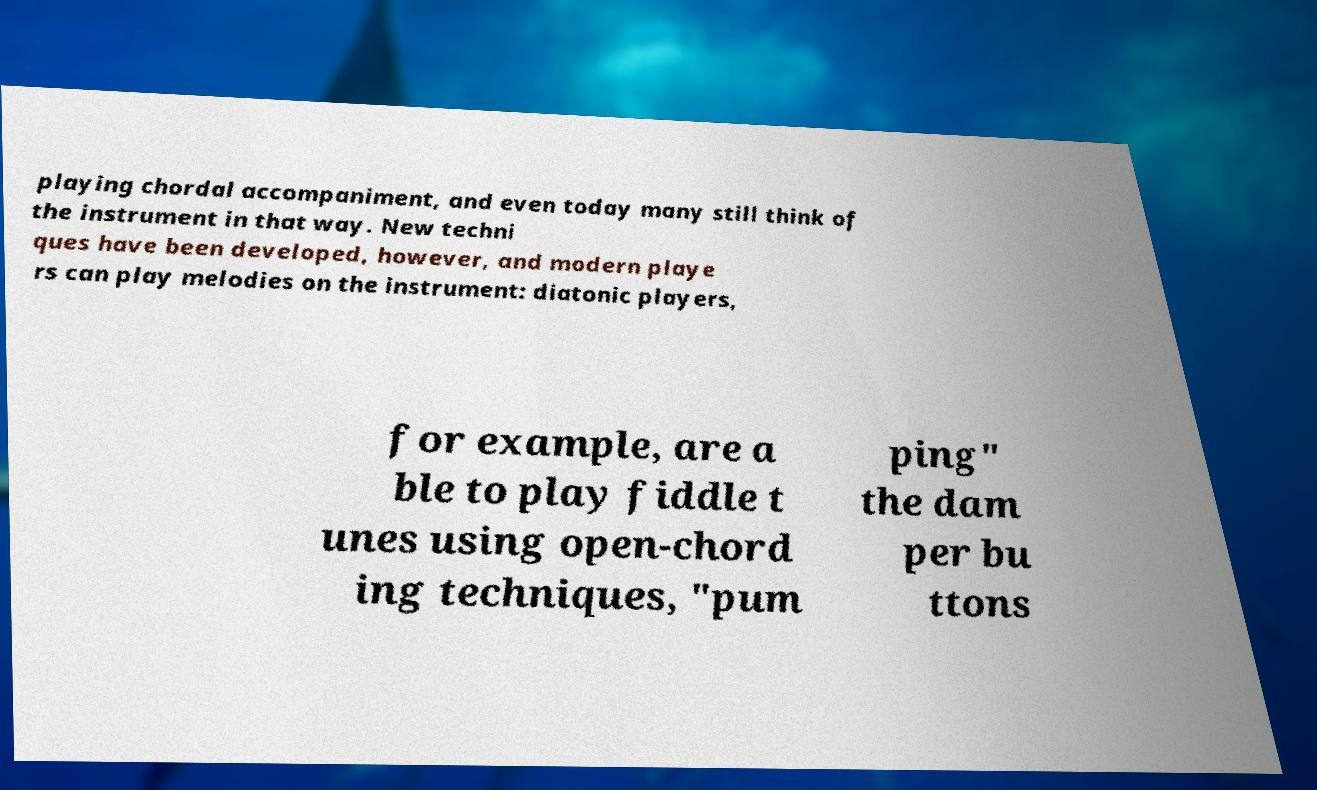Could you extract and type out the text from this image? playing chordal accompaniment, and even today many still think of the instrument in that way. New techni ques have been developed, however, and modern playe rs can play melodies on the instrument: diatonic players, for example, are a ble to play fiddle t unes using open-chord ing techniques, "pum ping" the dam per bu ttons 